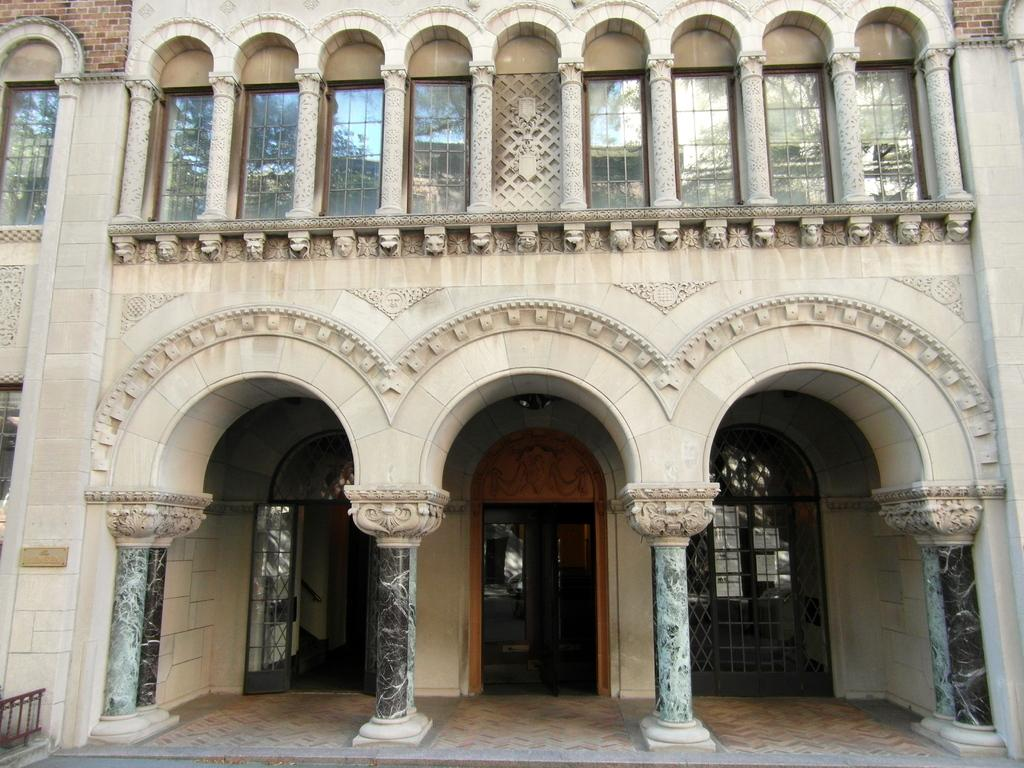What is the main structure in the image? There is a building in the center of the image. What feature of the building is visible from the outside? There is a door in the building. What architectural elements support the building? There are pillars in the building. How can natural light enter the building? There are windows in the building. What type of apparel is the donkey wearing in the image? There is no donkey or apparel present in the image. How many pizzas are being delivered to the building in the image? There is no mention of pizzas or delivery in the image. 